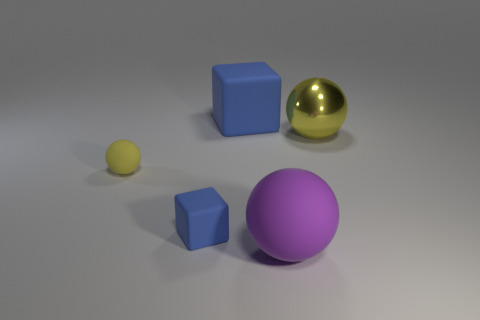Subtract all big balls. How many balls are left? 1 Add 4 green metal cylinders. How many objects exist? 9 Subtract all spheres. How many objects are left? 2 Subtract 0 cyan cubes. How many objects are left? 5 Subtract all tiny rubber balls. Subtract all big blue rubber objects. How many objects are left? 3 Add 2 big things. How many big things are left? 5 Add 2 big objects. How many big objects exist? 5 